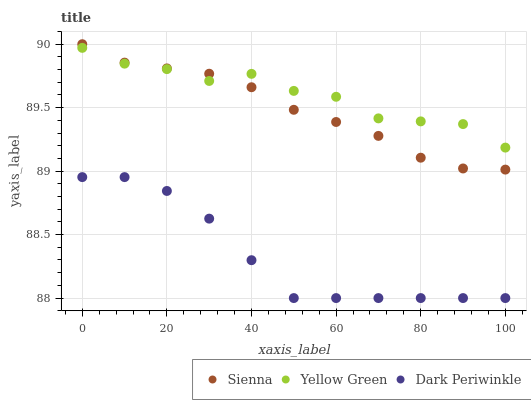Does Dark Periwinkle have the minimum area under the curve?
Answer yes or no. Yes. Does Yellow Green have the maximum area under the curve?
Answer yes or no. Yes. Does Yellow Green have the minimum area under the curve?
Answer yes or no. No. Does Dark Periwinkle have the maximum area under the curve?
Answer yes or no. No. Is Sienna the smoothest?
Answer yes or no. Yes. Is Yellow Green the roughest?
Answer yes or no. Yes. Is Dark Periwinkle the smoothest?
Answer yes or no. No. Is Dark Periwinkle the roughest?
Answer yes or no. No. Does Dark Periwinkle have the lowest value?
Answer yes or no. Yes. Does Yellow Green have the lowest value?
Answer yes or no. No. Does Sienna have the highest value?
Answer yes or no. Yes. Does Yellow Green have the highest value?
Answer yes or no. No. Is Dark Periwinkle less than Sienna?
Answer yes or no. Yes. Is Yellow Green greater than Dark Periwinkle?
Answer yes or no. Yes. Does Yellow Green intersect Sienna?
Answer yes or no. Yes. Is Yellow Green less than Sienna?
Answer yes or no. No. Is Yellow Green greater than Sienna?
Answer yes or no. No. Does Dark Periwinkle intersect Sienna?
Answer yes or no. No. 